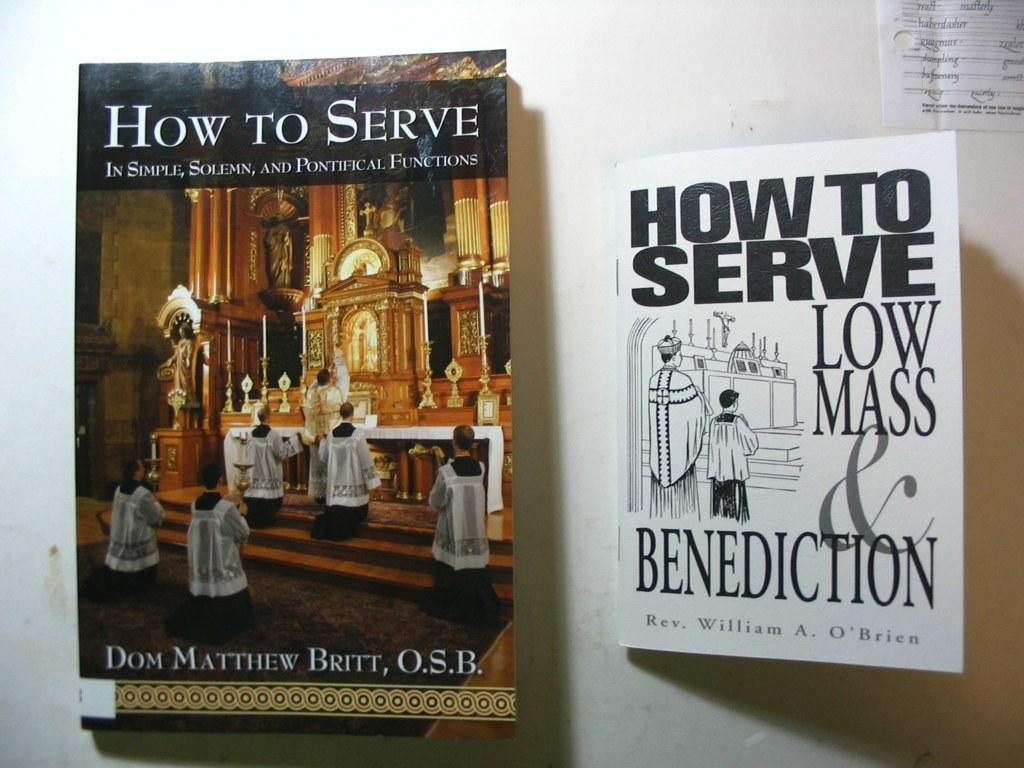<image>
Describe the image concisely. A copy of How to Serve has a full color image on the cover, while another copy is in black and white. 